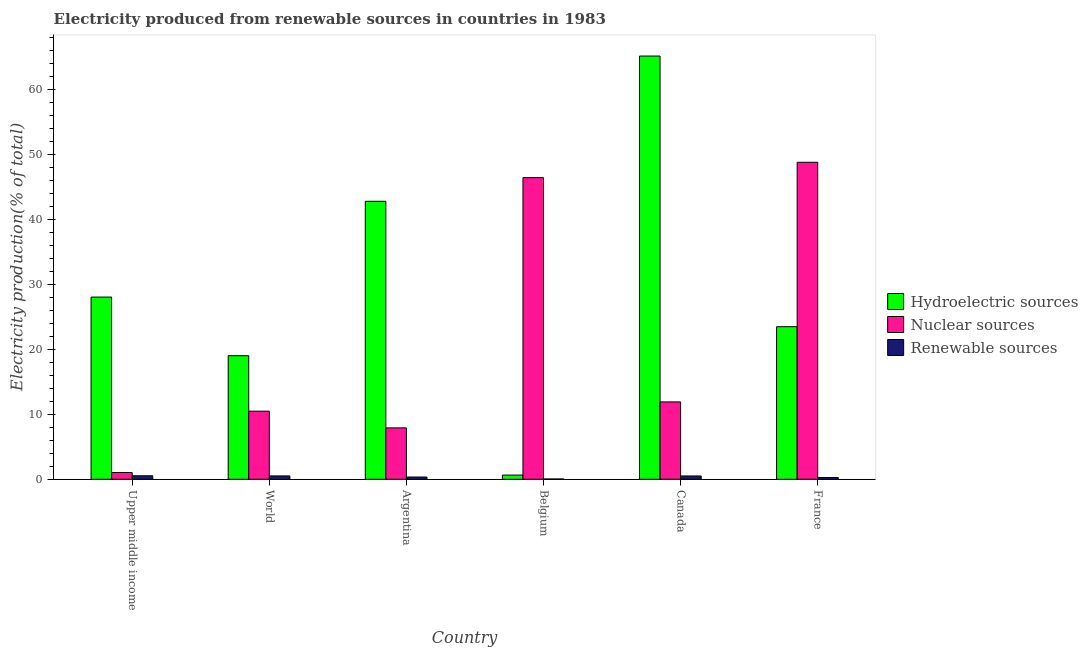How many different coloured bars are there?
Ensure brevity in your answer.  3. Are the number of bars per tick equal to the number of legend labels?
Your response must be concise. Yes. Are the number of bars on each tick of the X-axis equal?
Your response must be concise. Yes. How many bars are there on the 3rd tick from the left?
Ensure brevity in your answer.  3. How many bars are there on the 1st tick from the right?
Keep it short and to the point. 3. In how many cases, is the number of bars for a given country not equal to the number of legend labels?
Provide a short and direct response. 0. What is the percentage of electricity produced by nuclear sources in France?
Make the answer very short. 48.84. Across all countries, what is the maximum percentage of electricity produced by renewable sources?
Make the answer very short. 0.54. Across all countries, what is the minimum percentage of electricity produced by hydroelectric sources?
Give a very brief answer. 0.65. In which country was the percentage of electricity produced by renewable sources maximum?
Your answer should be compact. Upper middle income. In which country was the percentage of electricity produced by renewable sources minimum?
Keep it short and to the point. Belgium. What is the total percentage of electricity produced by renewable sources in the graph?
Make the answer very short. 2.23. What is the difference between the percentage of electricity produced by nuclear sources in Argentina and that in Upper middle income?
Offer a terse response. 6.88. What is the difference between the percentage of electricity produced by hydroelectric sources in Upper middle income and the percentage of electricity produced by renewable sources in World?
Your answer should be very brief. 27.56. What is the average percentage of electricity produced by nuclear sources per country?
Give a very brief answer. 21.12. What is the difference between the percentage of electricity produced by nuclear sources and percentage of electricity produced by renewable sources in Upper middle income?
Your answer should be compact. 0.5. What is the ratio of the percentage of electricity produced by renewable sources in Argentina to that in Canada?
Offer a very short reply. 0.68. Is the percentage of electricity produced by hydroelectric sources in Argentina less than that in Canada?
Keep it short and to the point. Yes. What is the difference between the highest and the second highest percentage of electricity produced by nuclear sources?
Your answer should be very brief. 2.37. What is the difference between the highest and the lowest percentage of electricity produced by hydroelectric sources?
Make the answer very short. 64.56. What does the 2nd bar from the left in Upper middle income represents?
Keep it short and to the point. Nuclear sources. What does the 1st bar from the right in Argentina represents?
Ensure brevity in your answer.  Renewable sources. Is it the case that in every country, the sum of the percentage of electricity produced by hydroelectric sources and percentage of electricity produced by nuclear sources is greater than the percentage of electricity produced by renewable sources?
Your response must be concise. Yes. How many bars are there?
Give a very brief answer. 18. What is the difference between two consecutive major ticks on the Y-axis?
Offer a terse response. 10. Does the graph contain any zero values?
Your response must be concise. No. Does the graph contain grids?
Provide a succinct answer. No. Where does the legend appear in the graph?
Your answer should be compact. Center right. How are the legend labels stacked?
Provide a succinct answer. Vertical. What is the title of the graph?
Provide a succinct answer. Electricity produced from renewable sources in countries in 1983. Does "Refusal of sex" appear as one of the legend labels in the graph?
Make the answer very short. No. What is the label or title of the X-axis?
Keep it short and to the point. Country. What is the Electricity production(% of total) of Hydroelectric sources in Upper middle income?
Provide a succinct answer. 28.07. What is the Electricity production(% of total) of Nuclear sources in Upper middle income?
Your answer should be compact. 1.04. What is the Electricity production(% of total) of Renewable sources in Upper middle income?
Your answer should be very brief. 0.54. What is the Electricity production(% of total) in Hydroelectric sources in World?
Your answer should be compact. 19.04. What is the Electricity production(% of total) of Nuclear sources in World?
Provide a short and direct response. 10.5. What is the Electricity production(% of total) of Renewable sources in World?
Offer a terse response. 0.52. What is the Electricity production(% of total) of Hydroelectric sources in Argentina?
Ensure brevity in your answer.  42.83. What is the Electricity production(% of total) of Nuclear sources in Argentina?
Provide a short and direct response. 7.92. What is the Electricity production(% of total) of Renewable sources in Argentina?
Provide a succinct answer. 0.35. What is the Electricity production(% of total) of Hydroelectric sources in Belgium?
Your answer should be very brief. 0.65. What is the Electricity production(% of total) of Nuclear sources in Belgium?
Ensure brevity in your answer.  46.47. What is the Electricity production(% of total) of Renewable sources in Belgium?
Your answer should be very brief. 0.04. What is the Electricity production(% of total) of Hydroelectric sources in Canada?
Offer a very short reply. 65.21. What is the Electricity production(% of total) of Nuclear sources in Canada?
Provide a succinct answer. 11.92. What is the Electricity production(% of total) in Renewable sources in Canada?
Give a very brief answer. 0.51. What is the Electricity production(% of total) in Hydroelectric sources in France?
Provide a succinct answer. 23.51. What is the Electricity production(% of total) in Nuclear sources in France?
Provide a succinct answer. 48.84. What is the Electricity production(% of total) in Renewable sources in France?
Keep it short and to the point. 0.27. Across all countries, what is the maximum Electricity production(% of total) in Hydroelectric sources?
Offer a very short reply. 65.21. Across all countries, what is the maximum Electricity production(% of total) of Nuclear sources?
Provide a short and direct response. 48.84. Across all countries, what is the maximum Electricity production(% of total) in Renewable sources?
Offer a very short reply. 0.54. Across all countries, what is the minimum Electricity production(% of total) in Hydroelectric sources?
Your answer should be compact. 0.65. Across all countries, what is the minimum Electricity production(% of total) of Nuclear sources?
Ensure brevity in your answer.  1.04. Across all countries, what is the minimum Electricity production(% of total) in Renewable sources?
Make the answer very short. 0.04. What is the total Electricity production(% of total) of Hydroelectric sources in the graph?
Make the answer very short. 179.31. What is the total Electricity production(% of total) of Nuclear sources in the graph?
Provide a short and direct response. 126.69. What is the total Electricity production(% of total) in Renewable sources in the graph?
Ensure brevity in your answer.  2.23. What is the difference between the Electricity production(% of total) of Hydroelectric sources in Upper middle income and that in World?
Give a very brief answer. 9.04. What is the difference between the Electricity production(% of total) in Nuclear sources in Upper middle income and that in World?
Your answer should be compact. -9.45. What is the difference between the Electricity production(% of total) of Renewable sources in Upper middle income and that in World?
Provide a succinct answer. 0.02. What is the difference between the Electricity production(% of total) in Hydroelectric sources in Upper middle income and that in Argentina?
Your answer should be very brief. -14.76. What is the difference between the Electricity production(% of total) in Nuclear sources in Upper middle income and that in Argentina?
Ensure brevity in your answer.  -6.88. What is the difference between the Electricity production(% of total) in Renewable sources in Upper middle income and that in Argentina?
Give a very brief answer. 0.19. What is the difference between the Electricity production(% of total) of Hydroelectric sources in Upper middle income and that in Belgium?
Provide a short and direct response. 27.43. What is the difference between the Electricity production(% of total) in Nuclear sources in Upper middle income and that in Belgium?
Your answer should be compact. -45.43. What is the difference between the Electricity production(% of total) of Renewable sources in Upper middle income and that in Belgium?
Provide a succinct answer. 0.5. What is the difference between the Electricity production(% of total) in Hydroelectric sources in Upper middle income and that in Canada?
Provide a short and direct response. -37.14. What is the difference between the Electricity production(% of total) of Nuclear sources in Upper middle income and that in Canada?
Offer a very short reply. -10.88. What is the difference between the Electricity production(% of total) of Renewable sources in Upper middle income and that in Canada?
Offer a very short reply. 0.03. What is the difference between the Electricity production(% of total) in Hydroelectric sources in Upper middle income and that in France?
Give a very brief answer. 4.57. What is the difference between the Electricity production(% of total) in Nuclear sources in Upper middle income and that in France?
Ensure brevity in your answer.  -47.8. What is the difference between the Electricity production(% of total) in Renewable sources in Upper middle income and that in France?
Provide a succinct answer. 0.27. What is the difference between the Electricity production(% of total) of Hydroelectric sources in World and that in Argentina?
Ensure brevity in your answer.  -23.79. What is the difference between the Electricity production(% of total) of Nuclear sources in World and that in Argentina?
Your response must be concise. 2.58. What is the difference between the Electricity production(% of total) in Renewable sources in World and that in Argentina?
Your answer should be very brief. 0.17. What is the difference between the Electricity production(% of total) in Hydroelectric sources in World and that in Belgium?
Provide a succinct answer. 18.39. What is the difference between the Electricity production(% of total) in Nuclear sources in World and that in Belgium?
Keep it short and to the point. -35.98. What is the difference between the Electricity production(% of total) of Renewable sources in World and that in Belgium?
Provide a succinct answer. 0.48. What is the difference between the Electricity production(% of total) in Hydroelectric sources in World and that in Canada?
Your answer should be very brief. -46.17. What is the difference between the Electricity production(% of total) of Nuclear sources in World and that in Canada?
Keep it short and to the point. -1.42. What is the difference between the Electricity production(% of total) in Renewable sources in World and that in Canada?
Offer a very short reply. 0.01. What is the difference between the Electricity production(% of total) in Hydroelectric sources in World and that in France?
Offer a very short reply. -4.47. What is the difference between the Electricity production(% of total) in Nuclear sources in World and that in France?
Offer a very short reply. -38.35. What is the difference between the Electricity production(% of total) of Renewable sources in World and that in France?
Provide a short and direct response. 0.25. What is the difference between the Electricity production(% of total) of Hydroelectric sources in Argentina and that in Belgium?
Offer a very short reply. 42.18. What is the difference between the Electricity production(% of total) of Nuclear sources in Argentina and that in Belgium?
Keep it short and to the point. -38.56. What is the difference between the Electricity production(% of total) of Renewable sources in Argentina and that in Belgium?
Your answer should be very brief. 0.31. What is the difference between the Electricity production(% of total) of Hydroelectric sources in Argentina and that in Canada?
Ensure brevity in your answer.  -22.38. What is the difference between the Electricity production(% of total) of Nuclear sources in Argentina and that in Canada?
Provide a succinct answer. -4. What is the difference between the Electricity production(% of total) in Renewable sources in Argentina and that in Canada?
Offer a very short reply. -0.16. What is the difference between the Electricity production(% of total) in Hydroelectric sources in Argentina and that in France?
Provide a short and direct response. 19.32. What is the difference between the Electricity production(% of total) in Nuclear sources in Argentina and that in France?
Ensure brevity in your answer.  -40.92. What is the difference between the Electricity production(% of total) of Renewable sources in Argentina and that in France?
Your answer should be very brief. 0.08. What is the difference between the Electricity production(% of total) of Hydroelectric sources in Belgium and that in Canada?
Give a very brief answer. -64.56. What is the difference between the Electricity production(% of total) in Nuclear sources in Belgium and that in Canada?
Your answer should be compact. 34.56. What is the difference between the Electricity production(% of total) in Renewable sources in Belgium and that in Canada?
Offer a terse response. -0.47. What is the difference between the Electricity production(% of total) of Hydroelectric sources in Belgium and that in France?
Make the answer very short. -22.86. What is the difference between the Electricity production(% of total) in Nuclear sources in Belgium and that in France?
Keep it short and to the point. -2.37. What is the difference between the Electricity production(% of total) of Renewable sources in Belgium and that in France?
Offer a very short reply. -0.23. What is the difference between the Electricity production(% of total) in Hydroelectric sources in Canada and that in France?
Provide a succinct answer. 41.7. What is the difference between the Electricity production(% of total) of Nuclear sources in Canada and that in France?
Your answer should be very brief. -36.92. What is the difference between the Electricity production(% of total) of Renewable sources in Canada and that in France?
Provide a short and direct response. 0.24. What is the difference between the Electricity production(% of total) of Hydroelectric sources in Upper middle income and the Electricity production(% of total) of Nuclear sources in World?
Your response must be concise. 17.58. What is the difference between the Electricity production(% of total) in Hydroelectric sources in Upper middle income and the Electricity production(% of total) in Renewable sources in World?
Give a very brief answer. 27.56. What is the difference between the Electricity production(% of total) of Nuclear sources in Upper middle income and the Electricity production(% of total) of Renewable sources in World?
Your answer should be compact. 0.52. What is the difference between the Electricity production(% of total) of Hydroelectric sources in Upper middle income and the Electricity production(% of total) of Nuclear sources in Argentina?
Offer a terse response. 20.16. What is the difference between the Electricity production(% of total) in Hydroelectric sources in Upper middle income and the Electricity production(% of total) in Renewable sources in Argentina?
Your answer should be very brief. 27.73. What is the difference between the Electricity production(% of total) in Nuclear sources in Upper middle income and the Electricity production(% of total) in Renewable sources in Argentina?
Your answer should be very brief. 0.69. What is the difference between the Electricity production(% of total) of Hydroelectric sources in Upper middle income and the Electricity production(% of total) of Nuclear sources in Belgium?
Offer a very short reply. -18.4. What is the difference between the Electricity production(% of total) in Hydroelectric sources in Upper middle income and the Electricity production(% of total) in Renewable sources in Belgium?
Provide a short and direct response. 28.03. What is the difference between the Electricity production(% of total) of Nuclear sources in Upper middle income and the Electricity production(% of total) of Renewable sources in Belgium?
Your answer should be very brief. 1. What is the difference between the Electricity production(% of total) of Hydroelectric sources in Upper middle income and the Electricity production(% of total) of Nuclear sources in Canada?
Offer a very short reply. 16.15. What is the difference between the Electricity production(% of total) of Hydroelectric sources in Upper middle income and the Electricity production(% of total) of Renewable sources in Canada?
Offer a terse response. 27.56. What is the difference between the Electricity production(% of total) of Nuclear sources in Upper middle income and the Electricity production(% of total) of Renewable sources in Canada?
Offer a very short reply. 0.53. What is the difference between the Electricity production(% of total) in Hydroelectric sources in Upper middle income and the Electricity production(% of total) in Nuclear sources in France?
Provide a succinct answer. -20.77. What is the difference between the Electricity production(% of total) in Hydroelectric sources in Upper middle income and the Electricity production(% of total) in Renewable sources in France?
Offer a very short reply. 27.8. What is the difference between the Electricity production(% of total) in Nuclear sources in Upper middle income and the Electricity production(% of total) in Renewable sources in France?
Keep it short and to the point. 0.77. What is the difference between the Electricity production(% of total) of Hydroelectric sources in World and the Electricity production(% of total) of Nuclear sources in Argentina?
Make the answer very short. 11.12. What is the difference between the Electricity production(% of total) in Hydroelectric sources in World and the Electricity production(% of total) in Renewable sources in Argentina?
Provide a short and direct response. 18.69. What is the difference between the Electricity production(% of total) in Nuclear sources in World and the Electricity production(% of total) in Renewable sources in Argentina?
Your response must be concise. 10.15. What is the difference between the Electricity production(% of total) of Hydroelectric sources in World and the Electricity production(% of total) of Nuclear sources in Belgium?
Your answer should be very brief. -27.44. What is the difference between the Electricity production(% of total) in Hydroelectric sources in World and the Electricity production(% of total) in Renewable sources in Belgium?
Provide a succinct answer. 18.99. What is the difference between the Electricity production(% of total) in Nuclear sources in World and the Electricity production(% of total) in Renewable sources in Belgium?
Your answer should be very brief. 10.45. What is the difference between the Electricity production(% of total) of Hydroelectric sources in World and the Electricity production(% of total) of Nuclear sources in Canada?
Make the answer very short. 7.12. What is the difference between the Electricity production(% of total) of Hydroelectric sources in World and the Electricity production(% of total) of Renewable sources in Canada?
Your answer should be compact. 18.53. What is the difference between the Electricity production(% of total) in Nuclear sources in World and the Electricity production(% of total) in Renewable sources in Canada?
Your answer should be compact. 9.98. What is the difference between the Electricity production(% of total) of Hydroelectric sources in World and the Electricity production(% of total) of Nuclear sources in France?
Provide a succinct answer. -29.81. What is the difference between the Electricity production(% of total) of Hydroelectric sources in World and the Electricity production(% of total) of Renewable sources in France?
Offer a very short reply. 18.77. What is the difference between the Electricity production(% of total) in Nuclear sources in World and the Electricity production(% of total) in Renewable sources in France?
Your answer should be very brief. 10.23. What is the difference between the Electricity production(% of total) in Hydroelectric sources in Argentina and the Electricity production(% of total) in Nuclear sources in Belgium?
Give a very brief answer. -3.64. What is the difference between the Electricity production(% of total) of Hydroelectric sources in Argentina and the Electricity production(% of total) of Renewable sources in Belgium?
Provide a short and direct response. 42.79. What is the difference between the Electricity production(% of total) of Nuclear sources in Argentina and the Electricity production(% of total) of Renewable sources in Belgium?
Make the answer very short. 7.88. What is the difference between the Electricity production(% of total) of Hydroelectric sources in Argentina and the Electricity production(% of total) of Nuclear sources in Canada?
Make the answer very short. 30.91. What is the difference between the Electricity production(% of total) in Hydroelectric sources in Argentina and the Electricity production(% of total) in Renewable sources in Canada?
Provide a short and direct response. 42.32. What is the difference between the Electricity production(% of total) in Nuclear sources in Argentina and the Electricity production(% of total) in Renewable sources in Canada?
Make the answer very short. 7.41. What is the difference between the Electricity production(% of total) of Hydroelectric sources in Argentina and the Electricity production(% of total) of Nuclear sources in France?
Offer a terse response. -6.01. What is the difference between the Electricity production(% of total) of Hydroelectric sources in Argentina and the Electricity production(% of total) of Renewable sources in France?
Offer a terse response. 42.56. What is the difference between the Electricity production(% of total) in Nuclear sources in Argentina and the Electricity production(% of total) in Renewable sources in France?
Your response must be concise. 7.65. What is the difference between the Electricity production(% of total) of Hydroelectric sources in Belgium and the Electricity production(% of total) of Nuclear sources in Canada?
Your answer should be very brief. -11.27. What is the difference between the Electricity production(% of total) in Hydroelectric sources in Belgium and the Electricity production(% of total) in Renewable sources in Canada?
Your response must be concise. 0.14. What is the difference between the Electricity production(% of total) of Nuclear sources in Belgium and the Electricity production(% of total) of Renewable sources in Canada?
Your response must be concise. 45.96. What is the difference between the Electricity production(% of total) in Hydroelectric sources in Belgium and the Electricity production(% of total) in Nuclear sources in France?
Your answer should be very brief. -48.19. What is the difference between the Electricity production(% of total) in Hydroelectric sources in Belgium and the Electricity production(% of total) in Renewable sources in France?
Provide a short and direct response. 0.38. What is the difference between the Electricity production(% of total) of Nuclear sources in Belgium and the Electricity production(% of total) of Renewable sources in France?
Provide a succinct answer. 46.21. What is the difference between the Electricity production(% of total) in Hydroelectric sources in Canada and the Electricity production(% of total) in Nuclear sources in France?
Offer a terse response. 16.37. What is the difference between the Electricity production(% of total) of Hydroelectric sources in Canada and the Electricity production(% of total) of Renewable sources in France?
Offer a very short reply. 64.94. What is the difference between the Electricity production(% of total) in Nuclear sources in Canada and the Electricity production(% of total) in Renewable sources in France?
Offer a terse response. 11.65. What is the average Electricity production(% of total) of Hydroelectric sources per country?
Your response must be concise. 29.89. What is the average Electricity production(% of total) in Nuclear sources per country?
Offer a very short reply. 21.12. What is the average Electricity production(% of total) of Renewable sources per country?
Offer a very short reply. 0.37. What is the difference between the Electricity production(% of total) of Hydroelectric sources and Electricity production(% of total) of Nuclear sources in Upper middle income?
Your answer should be compact. 27.03. What is the difference between the Electricity production(% of total) in Hydroelectric sources and Electricity production(% of total) in Renewable sources in Upper middle income?
Your answer should be very brief. 27.53. What is the difference between the Electricity production(% of total) of Nuclear sources and Electricity production(% of total) of Renewable sources in Upper middle income?
Make the answer very short. 0.5. What is the difference between the Electricity production(% of total) in Hydroelectric sources and Electricity production(% of total) in Nuclear sources in World?
Offer a terse response. 8.54. What is the difference between the Electricity production(% of total) in Hydroelectric sources and Electricity production(% of total) in Renewable sources in World?
Ensure brevity in your answer.  18.52. What is the difference between the Electricity production(% of total) of Nuclear sources and Electricity production(% of total) of Renewable sources in World?
Make the answer very short. 9.98. What is the difference between the Electricity production(% of total) in Hydroelectric sources and Electricity production(% of total) in Nuclear sources in Argentina?
Offer a terse response. 34.91. What is the difference between the Electricity production(% of total) in Hydroelectric sources and Electricity production(% of total) in Renewable sources in Argentina?
Give a very brief answer. 42.48. What is the difference between the Electricity production(% of total) of Nuclear sources and Electricity production(% of total) of Renewable sources in Argentina?
Your response must be concise. 7.57. What is the difference between the Electricity production(% of total) in Hydroelectric sources and Electricity production(% of total) in Nuclear sources in Belgium?
Your answer should be compact. -45.83. What is the difference between the Electricity production(% of total) in Hydroelectric sources and Electricity production(% of total) in Renewable sources in Belgium?
Keep it short and to the point. 0.61. What is the difference between the Electricity production(% of total) of Nuclear sources and Electricity production(% of total) of Renewable sources in Belgium?
Ensure brevity in your answer.  46.43. What is the difference between the Electricity production(% of total) in Hydroelectric sources and Electricity production(% of total) in Nuclear sources in Canada?
Ensure brevity in your answer.  53.29. What is the difference between the Electricity production(% of total) of Hydroelectric sources and Electricity production(% of total) of Renewable sources in Canada?
Provide a short and direct response. 64.7. What is the difference between the Electricity production(% of total) in Nuclear sources and Electricity production(% of total) in Renewable sources in Canada?
Give a very brief answer. 11.41. What is the difference between the Electricity production(% of total) of Hydroelectric sources and Electricity production(% of total) of Nuclear sources in France?
Provide a succinct answer. -25.33. What is the difference between the Electricity production(% of total) in Hydroelectric sources and Electricity production(% of total) in Renewable sources in France?
Make the answer very short. 23.24. What is the difference between the Electricity production(% of total) in Nuclear sources and Electricity production(% of total) in Renewable sources in France?
Your response must be concise. 48.57. What is the ratio of the Electricity production(% of total) of Hydroelectric sources in Upper middle income to that in World?
Your answer should be compact. 1.47. What is the ratio of the Electricity production(% of total) of Nuclear sources in Upper middle income to that in World?
Your answer should be compact. 0.1. What is the ratio of the Electricity production(% of total) of Renewable sources in Upper middle income to that in World?
Your answer should be very brief. 1.05. What is the ratio of the Electricity production(% of total) of Hydroelectric sources in Upper middle income to that in Argentina?
Give a very brief answer. 0.66. What is the ratio of the Electricity production(% of total) in Nuclear sources in Upper middle income to that in Argentina?
Provide a short and direct response. 0.13. What is the ratio of the Electricity production(% of total) in Renewable sources in Upper middle income to that in Argentina?
Your response must be concise. 1.55. What is the ratio of the Electricity production(% of total) in Hydroelectric sources in Upper middle income to that in Belgium?
Make the answer very short. 43.34. What is the ratio of the Electricity production(% of total) in Nuclear sources in Upper middle income to that in Belgium?
Provide a succinct answer. 0.02. What is the ratio of the Electricity production(% of total) of Renewable sources in Upper middle income to that in Belgium?
Ensure brevity in your answer.  12.77. What is the ratio of the Electricity production(% of total) in Hydroelectric sources in Upper middle income to that in Canada?
Your answer should be very brief. 0.43. What is the ratio of the Electricity production(% of total) of Nuclear sources in Upper middle income to that in Canada?
Offer a very short reply. 0.09. What is the ratio of the Electricity production(% of total) of Renewable sources in Upper middle income to that in Canada?
Ensure brevity in your answer.  1.06. What is the ratio of the Electricity production(% of total) of Hydroelectric sources in Upper middle income to that in France?
Make the answer very short. 1.19. What is the ratio of the Electricity production(% of total) in Nuclear sources in Upper middle income to that in France?
Ensure brevity in your answer.  0.02. What is the ratio of the Electricity production(% of total) of Renewable sources in Upper middle income to that in France?
Make the answer very short. 2.01. What is the ratio of the Electricity production(% of total) in Hydroelectric sources in World to that in Argentina?
Make the answer very short. 0.44. What is the ratio of the Electricity production(% of total) in Nuclear sources in World to that in Argentina?
Make the answer very short. 1.33. What is the ratio of the Electricity production(% of total) in Renewable sources in World to that in Argentina?
Give a very brief answer. 1.48. What is the ratio of the Electricity production(% of total) in Hydroelectric sources in World to that in Belgium?
Offer a terse response. 29.39. What is the ratio of the Electricity production(% of total) of Nuclear sources in World to that in Belgium?
Offer a terse response. 0.23. What is the ratio of the Electricity production(% of total) in Renewable sources in World to that in Belgium?
Offer a terse response. 12.21. What is the ratio of the Electricity production(% of total) of Hydroelectric sources in World to that in Canada?
Give a very brief answer. 0.29. What is the ratio of the Electricity production(% of total) in Nuclear sources in World to that in Canada?
Offer a very short reply. 0.88. What is the ratio of the Electricity production(% of total) in Renewable sources in World to that in Canada?
Offer a terse response. 1.01. What is the ratio of the Electricity production(% of total) in Hydroelectric sources in World to that in France?
Ensure brevity in your answer.  0.81. What is the ratio of the Electricity production(% of total) in Nuclear sources in World to that in France?
Give a very brief answer. 0.21. What is the ratio of the Electricity production(% of total) of Renewable sources in World to that in France?
Your answer should be compact. 1.92. What is the ratio of the Electricity production(% of total) of Hydroelectric sources in Argentina to that in Belgium?
Provide a succinct answer. 66.12. What is the ratio of the Electricity production(% of total) in Nuclear sources in Argentina to that in Belgium?
Your answer should be compact. 0.17. What is the ratio of the Electricity production(% of total) of Renewable sources in Argentina to that in Belgium?
Your answer should be very brief. 8.22. What is the ratio of the Electricity production(% of total) in Hydroelectric sources in Argentina to that in Canada?
Ensure brevity in your answer.  0.66. What is the ratio of the Electricity production(% of total) of Nuclear sources in Argentina to that in Canada?
Keep it short and to the point. 0.66. What is the ratio of the Electricity production(% of total) of Renewable sources in Argentina to that in Canada?
Provide a short and direct response. 0.68. What is the ratio of the Electricity production(% of total) of Hydroelectric sources in Argentina to that in France?
Your response must be concise. 1.82. What is the ratio of the Electricity production(% of total) in Nuclear sources in Argentina to that in France?
Ensure brevity in your answer.  0.16. What is the ratio of the Electricity production(% of total) of Renewable sources in Argentina to that in France?
Offer a terse response. 1.29. What is the ratio of the Electricity production(% of total) in Hydroelectric sources in Belgium to that in Canada?
Your response must be concise. 0.01. What is the ratio of the Electricity production(% of total) in Nuclear sources in Belgium to that in Canada?
Provide a succinct answer. 3.9. What is the ratio of the Electricity production(% of total) in Renewable sources in Belgium to that in Canada?
Keep it short and to the point. 0.08. What is the ratio of the Electricity production(% of total) of Hydroelectric sources in Belgium to that in France?
Give a very brief answer. 0.03. What is the ratio of the Electricity production(% of total) in Nuclear sources in Belgium to that in France?
Ensure brevity in your answer.  0.95. What is the ratio of the Electricity production(% of total) of Renewable sources in Belgium to that in France?
Provide a short and direct response. 0.16. What is the ratio of the Electricity production(% of total) in Hydroelectric sources in Canada to that in France?
Keep it short and to the point. 2.77. What is the ratio of the Electricity production(% of total) of Nuclear sources in Canada to that in France?
Offer a terse response. 0.24. What is the ratio of the Electricity production(% of total) in Renewable sources in Canada to that in France?
Keep it short and to the point. 1.9. What is the difference between the highest and the second highest Electricity production(% of total) in Hydroelectric sources?
Offer a terse response. 22.38. What is the difference between the highest and the second highest Electricity production(% of total) in Nuclear sources?
Your answer should be very brief. 2.37. What is the difference between the highest and the second highest Electricity production(% of total) of Renewable sources?
Keep it short and to the point. 0.02. What is the difference between the highest and the lowest Electricity production(% of total) in Hydroelectric sources?
Provide a short and direct response. 64.56. What is the difference between the highest and the lowest Electricity production(% of total) of Nuclear sources?
Offer a terse response. 47.8. What is the difference between the highest and the lowest Electricity production(% of total) in Renewable sources?
Offer a terse response. 0.5. 